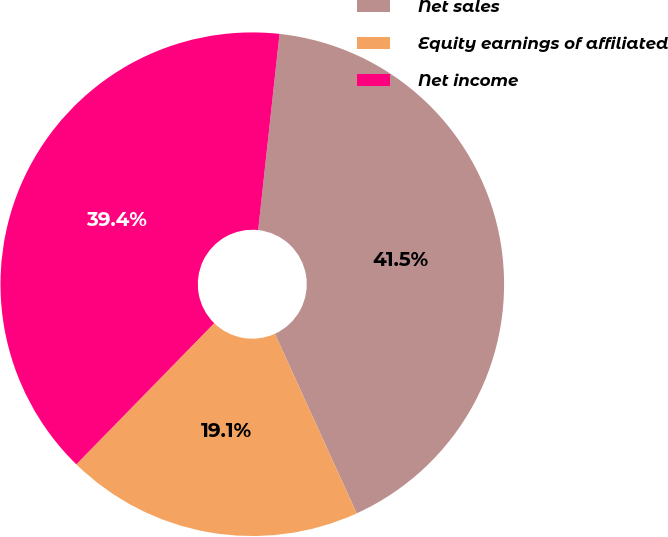Convert chart. <chart><loc_0><loc_0><loc_500><loc_500><pie_chart><fcel>Net sales<fcel>Equity earnings of affiliated<fcel>Net income<nl><fcel>41.47%<fcel>19.12%<fcel>39.41%<nl></chart> 